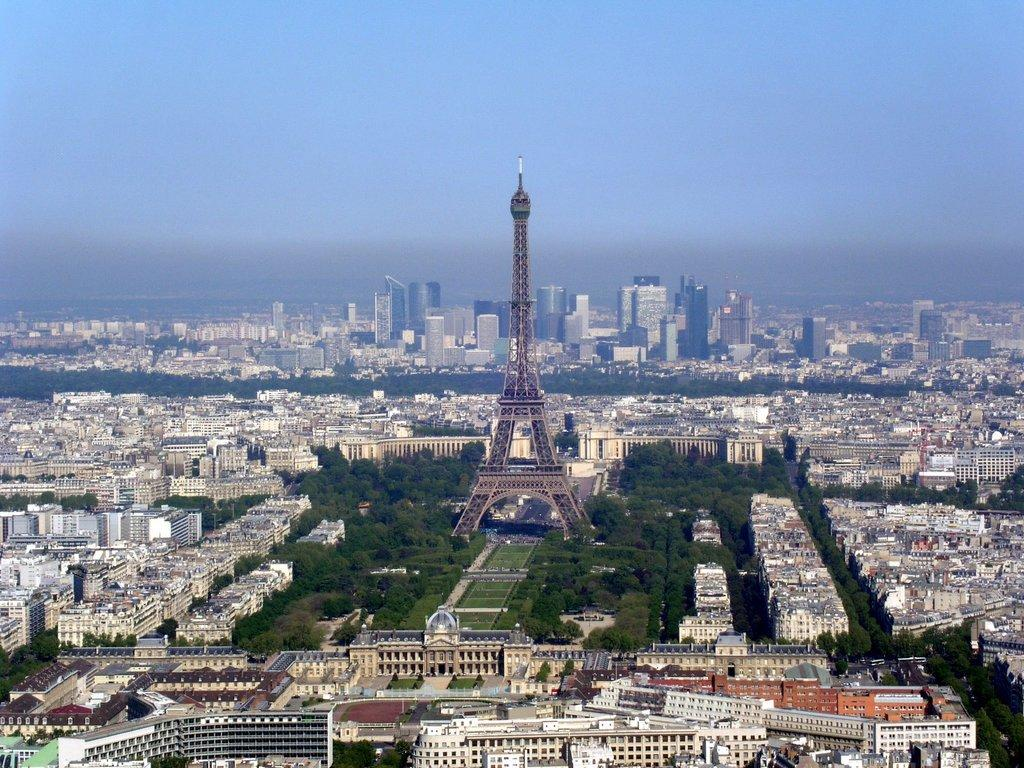What famous landmark can be seen in the image? There is an Eiffel Tower in the image. What type of location is depicted in the image? The image shows a view of the city. What tall structures are visible in the image? Skyscrapers are visible in the image. What type of structures can be seen in the image? There are buildings in the image. What natural elements are present in the image? Trees are present in the image. What color is the grip of the Eiffel Tower in the image? The Eiffel Tower does not have a grip, and its color cannot be determined from the image. 